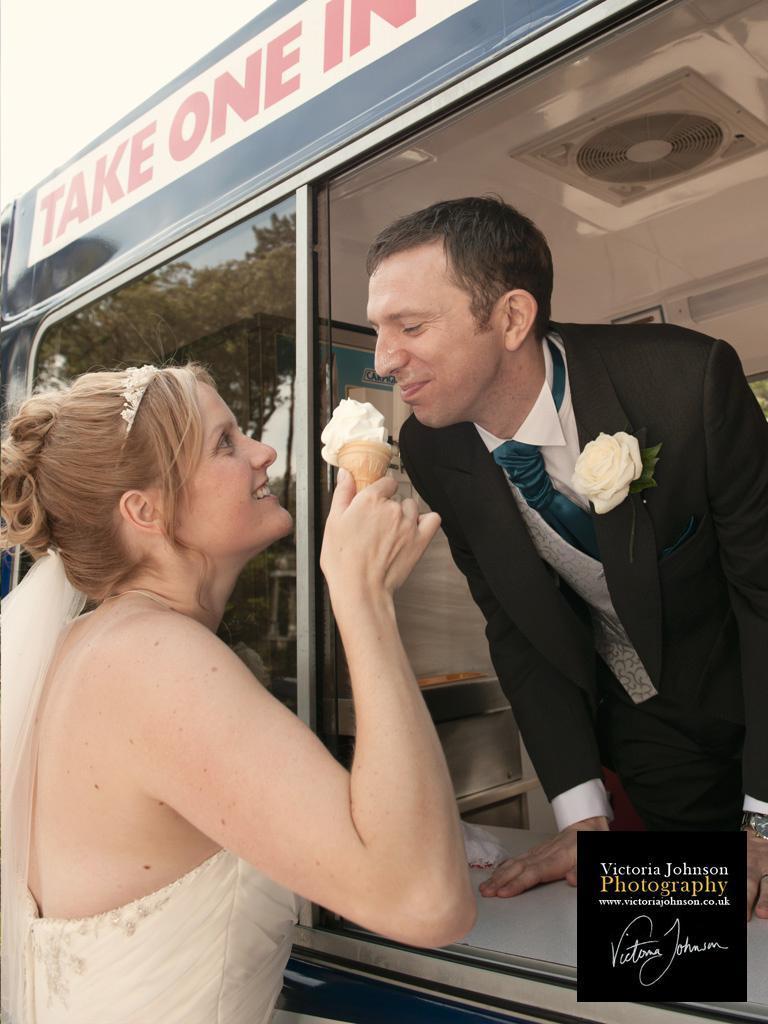In one or two sentences, can you explain what this image depicts? In this image I can see two persons standing. The person at right wearing black blazer and white shirt, and the person at left wearing white color dress. Background I can see a vehicle and sky is in white color. 